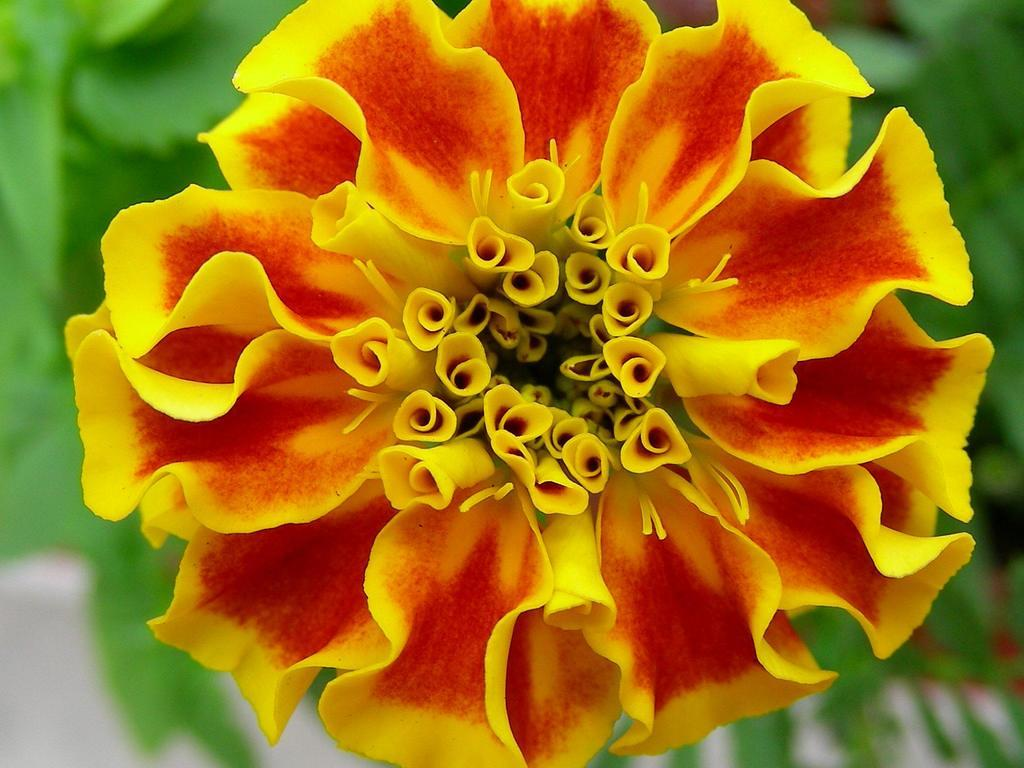What type of flower is in the image? There is a red and yellow color flower in the image. What colors can be seen in the flower? The flower has red and yellow colors. What is the background of the image? The background of the image is green and blurred. How many fish can be seen swimming in the background of the image? There are no fish present in the image; the background is green and blurred. 